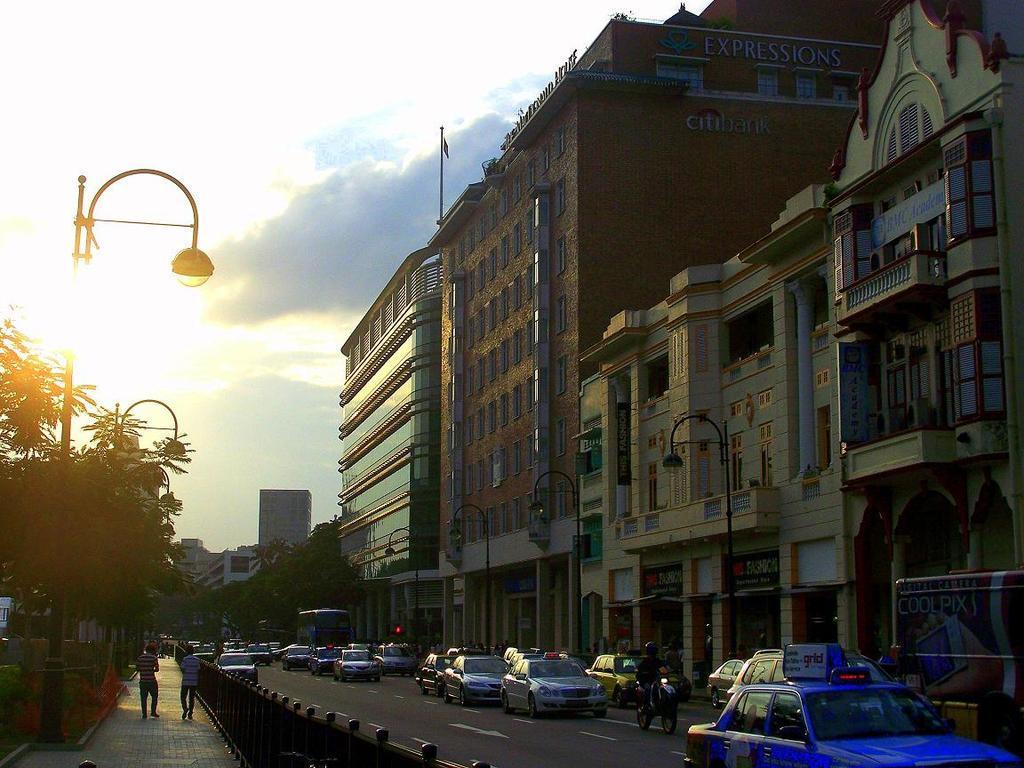Can you describe this image briefly? On the left there are trees, streetlight, railing, people, footpath and sun. In the center of the picture there are cars moving on the road. On the right there are buildings. In the center of the background there are trees and buildings. At the top there is sky. 